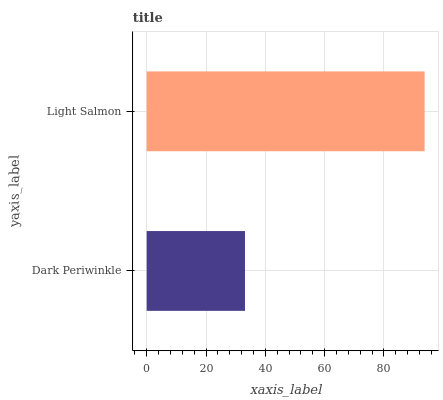Is Dark Periwinkle the minimum?
Answer yes or no. Yes. Is Light Salmon the maximum?
Answer yes or no. Yes. Is Light Salmon the minimum?
Answer yes or no. No. Is Light Salmon greater than Dark Periwinkle?
Answer yes or no. Yes. Is Dark Periwinkle less than Light Salmon?
Answer yes or no. Yes. Is Dark Periwinkle greater than Light Salmon?
Answer yes or no. No. Is Light Salmon less than Dark Periwinkle?
Answer yes or no. No. Is Light Salmon the high median?
Answer yes or no. Yes. Is Dark Periwinkle the low median?
Answer yes or no. Yes. Is Dark Periwinkle the high median?
Answer yes or no. No. Is Light Salmon the low median?
Answer yes or no. No. 